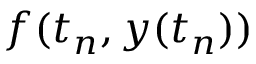<formula> <loc_0><loc_0><loc_500><loc_500>f ( t _ { n } , y ( t _ { n } ) )</formula> 